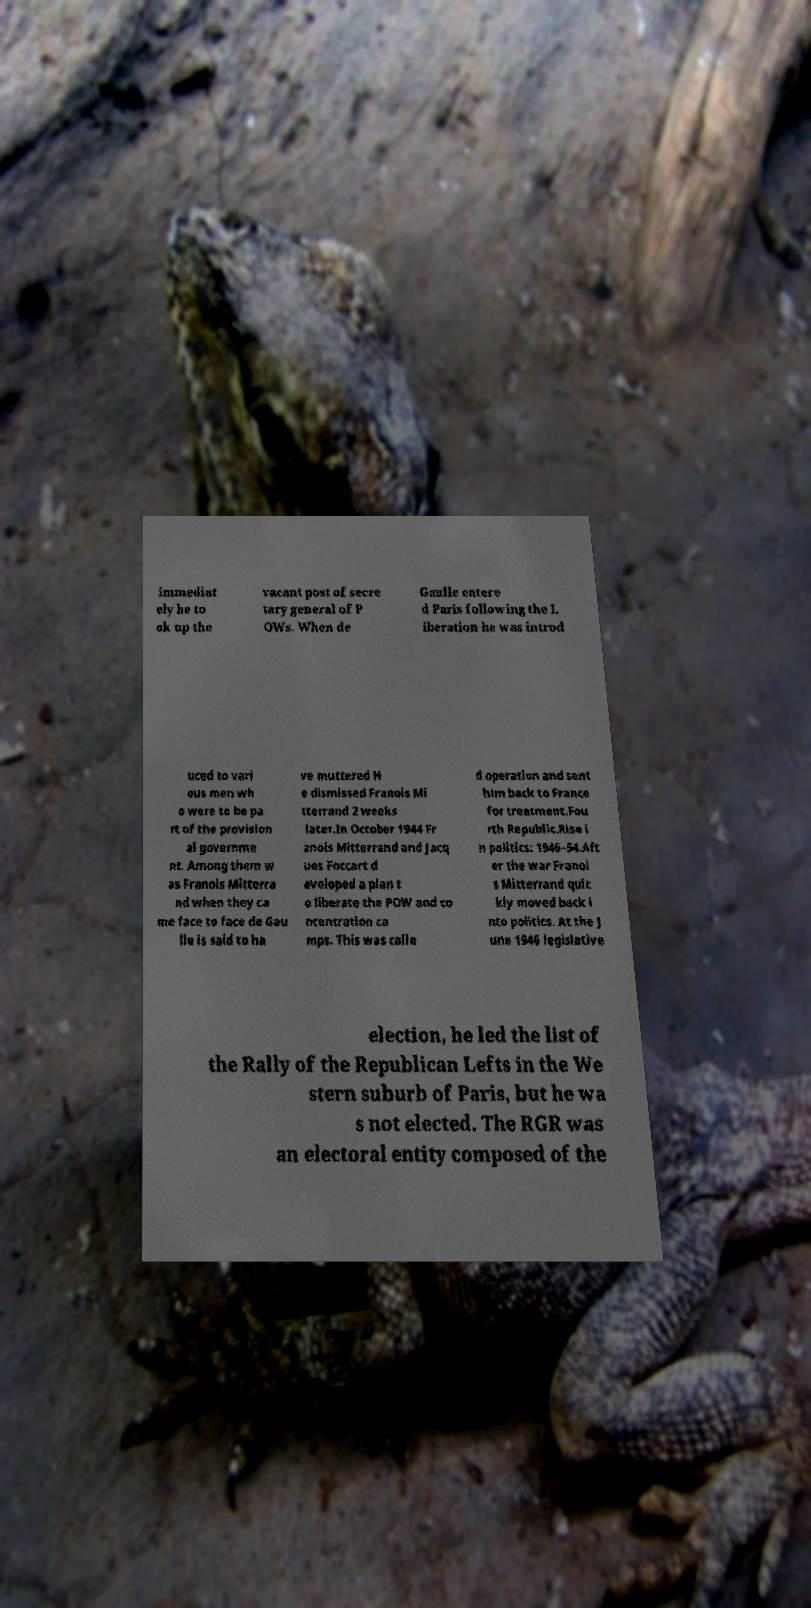Could you assist in decoding the text presented in this image and type it out clearly? immediat ely he to ok up the vacant post of secre tary general of P OWs. When de Gaulle entere d Paris following the L iberation he was introd uced to vari ous men wh o were to be pa rt of the provision al governme nt. Among them w as Franois Mitterra nd when they ca me face to face de Gau lle is said to ha ve muttered H e dismissed Franois Mi tterrand 2 weeks later.In October 1944 Fr anois Mitterrand and Jacq ues Foccart d eveloped a plan t o liberate the POW and co ncentration ca mps. This was calle d operation and sent him back to France for treatment.Fou rth Republic.Rise i n politics: 1946–54.Aft er the war Franoi s Mitterrand quic kly moved back i nto politics. At the J une 1946 legislative election, he led the list of the Rally of the Republican Lefts in the We stern suburb of Paris, but he wa s not elected. The RGR was an electoral entity composed of the 